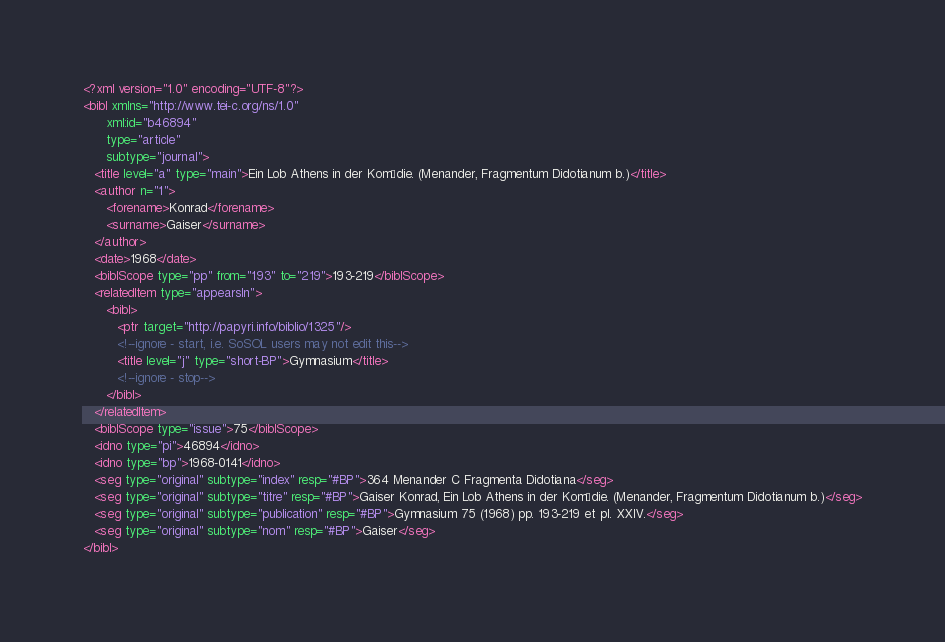Convert code to text. <code><loc_0><loc_0><loc_500><loc_500><_XML_><?xml version="1.0" encoding="UTF-8"?>
<bibl xmlns="http://www.tei-c.org/ns/1.0"
      xml:id="b46894"
      type="article"
      subtype="journal">
   <title level="a" type="main">Ein Lob Athens in der Komödie. (Menander, Fragmentum Didotianum b.)</title>
   <author n="1">
      <forename>Konrad</forename>
      <surname>Gaiser</surname>
   </author>
   <date>1968</date>
   <biblScope type="pp" from="193" to="219">193-219</biblScope>
   <relatedItem type="appearsIn">
      <bibl>
         <ptr target="http://papyri.info/biblio/1325"/>
         <!--ignore - start, i.e. SoSOL users may not edit this-->
         <title level="j" type="short-BP">Gymnasium</title>
         <!--ignore - stop-->
      </bibl>
   </relatedItem>
   <biblScope type="issue">75</biblScope>
   <idno type="pi">46894</idno>
   <idno type="bp">1968-0141</idno>
   <seg type="original" subtype="index" resp="#BP">364 Menander C Fragmenta Didotiana</seg>
   <seg type="original" subtype="titre" resp="#BP">Gaiser Konrad, Ein Lob Athens in der Komödie. (Menander, Fragmentum Didotianum b.)</seg>
   <seg type="original" subtype="publication" resp="#BP">Gymnasium 75 (1968) pp. 193-219 et pl. XXIV.</seg>
   <seg type="original" subtype="nom" resp="#BP">Gaiser</seg>
</bibl>
</code> 